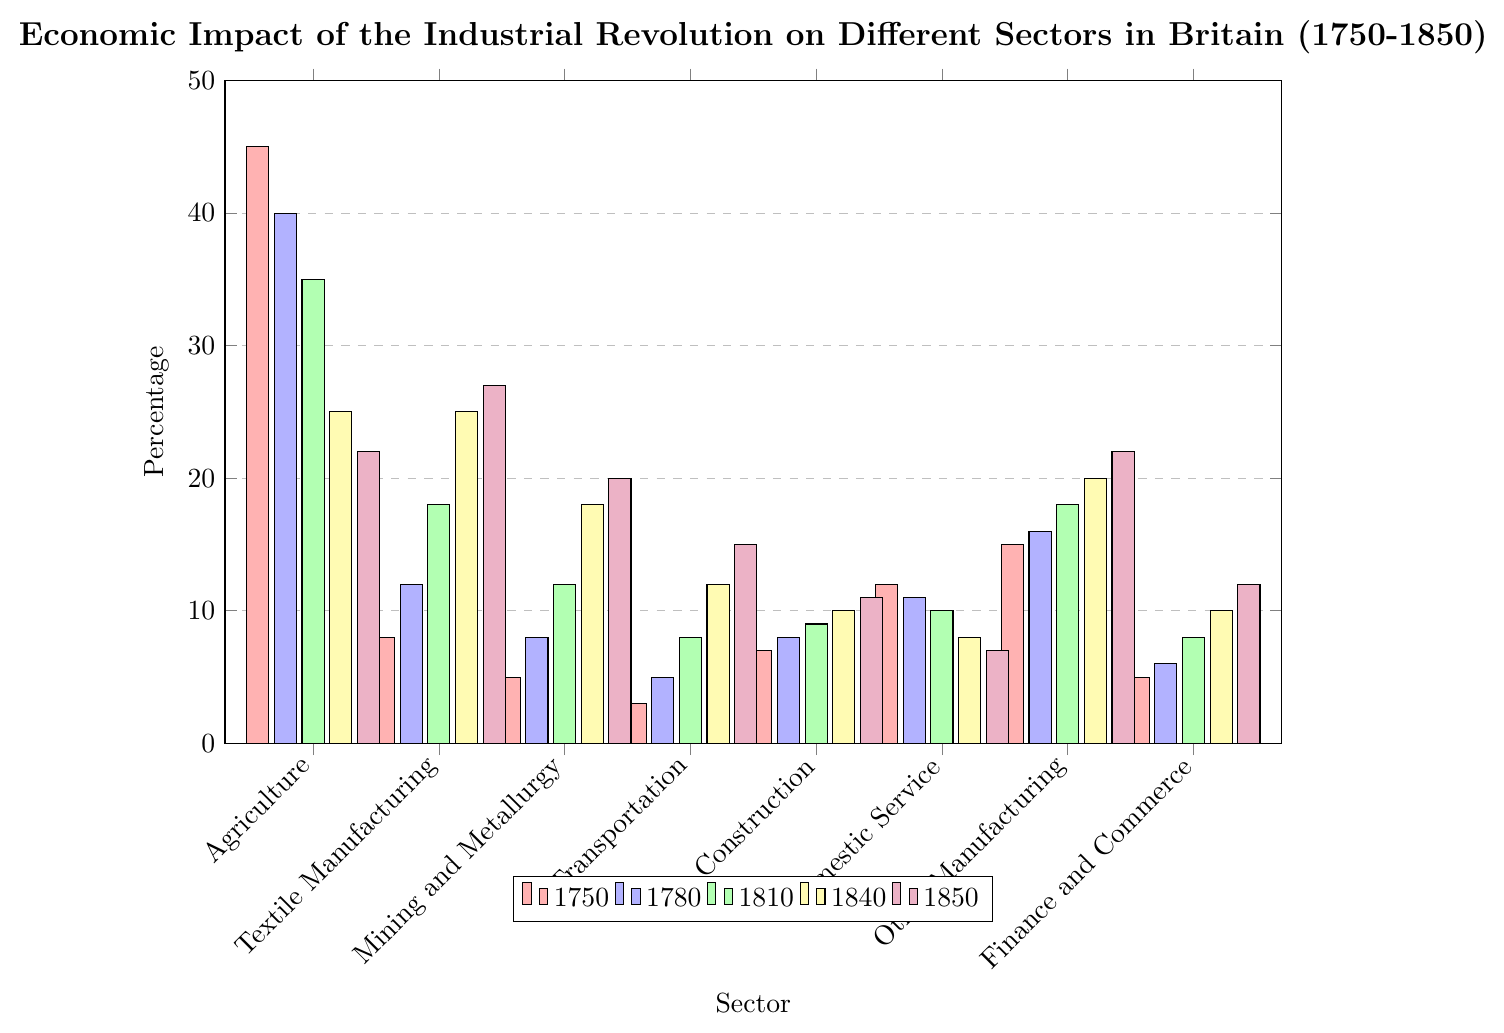What sector experienced the greatest percentage decline from 1750 to 1850? To find the sector with the greatest percentage decline, compare the percentages for 1750 and 1850. Agriculture dropped from 45% to 22%, the other sectors experienced less decline.
Answer: Agriculture Which sector saw the largest increase in percentage from 1750 to 1850? To find the sector with the largest percentage increase, compare each sector's values for 1750 and 1850. Textile Manufacturing increased from 8% to 27%, which is the largest increase.
Answer: Textile Manufacturing How did the percentage of Agriculture change between 1750 and 1810? Agriculture in 1750 was at 45% and in 1810 it was at 35%. The change can be found by calculating 45 - 35.
Answer: Decreased by 10% Which sector had the smallest relative change in percentage from 1750 to 1850? To find the smallest relative change, look at the differences between 1750 and 1850 for each sector. Construction changed from 7% to 11%, a 4% change, which is the smallest.
Answer: Construction What is the average percentage of Finance and Commerce across all years shown? Add the values for Finance and Commerce for each year (5 + 6 + 8 + 10 + 12) and divide by the number of years (5).
Answer: 8.2% Which sectors were below 10% in 1750 and above 10% in 1850? Sectors below 10% in 1750 are Textile Manufacturing, Mining and Metallurgy, Transportation, and Finance and Commerce. Of these, Textile Manufacturing, Mining and Metallurgy, and Finance and Commerce reached above 10% by 1850.
Answer: Textile Manufacturing, Mining and Metallurgy, Finance and Commerce In which year did Textile Manufacturing surpass Agriculture in percentage? Observe the percentages of Textile Manufacturing and Agriculture over the years. Textile Manufacturing surpasses Agriculture between 1810 and 1840 (25% vs 35% and then 25% vs 22%).
Answer: 1840 Compare the percentage changes in Mining and Metallurgy from 1750 to 1810 with those from 1810 to 1850. Mining and Metallurgy increased from 5% to 12% from 1750 to 1810 (a 7% increase) and from 12% to 20% from 1810 to 1850 (an 8% increase).
Answer: 7%, 8% How much did the percentage of Transportation increase from 1750 to 1850? Transportation increased from 3% to 15% from 1750 to 1850. The increase is calculated by 15 - 3.
Answer: 12% Which sector had a higher percentage in 1810, Mining and Metallurgy or Domestic Service, and by how much? In 1810, Mining and Metallurgy was at 12%, and Domestic Service was at 10%. The difference is calculated by 12 - 10.
Answer: Mining and Metallurgy by 2% 